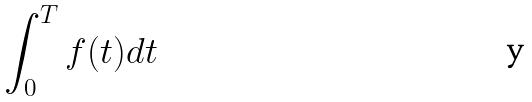<formula> <loc_0><loc_0><loc_500><loc_500>\int _ { 0 } ^ { T } f ( t ) d t</formula> 